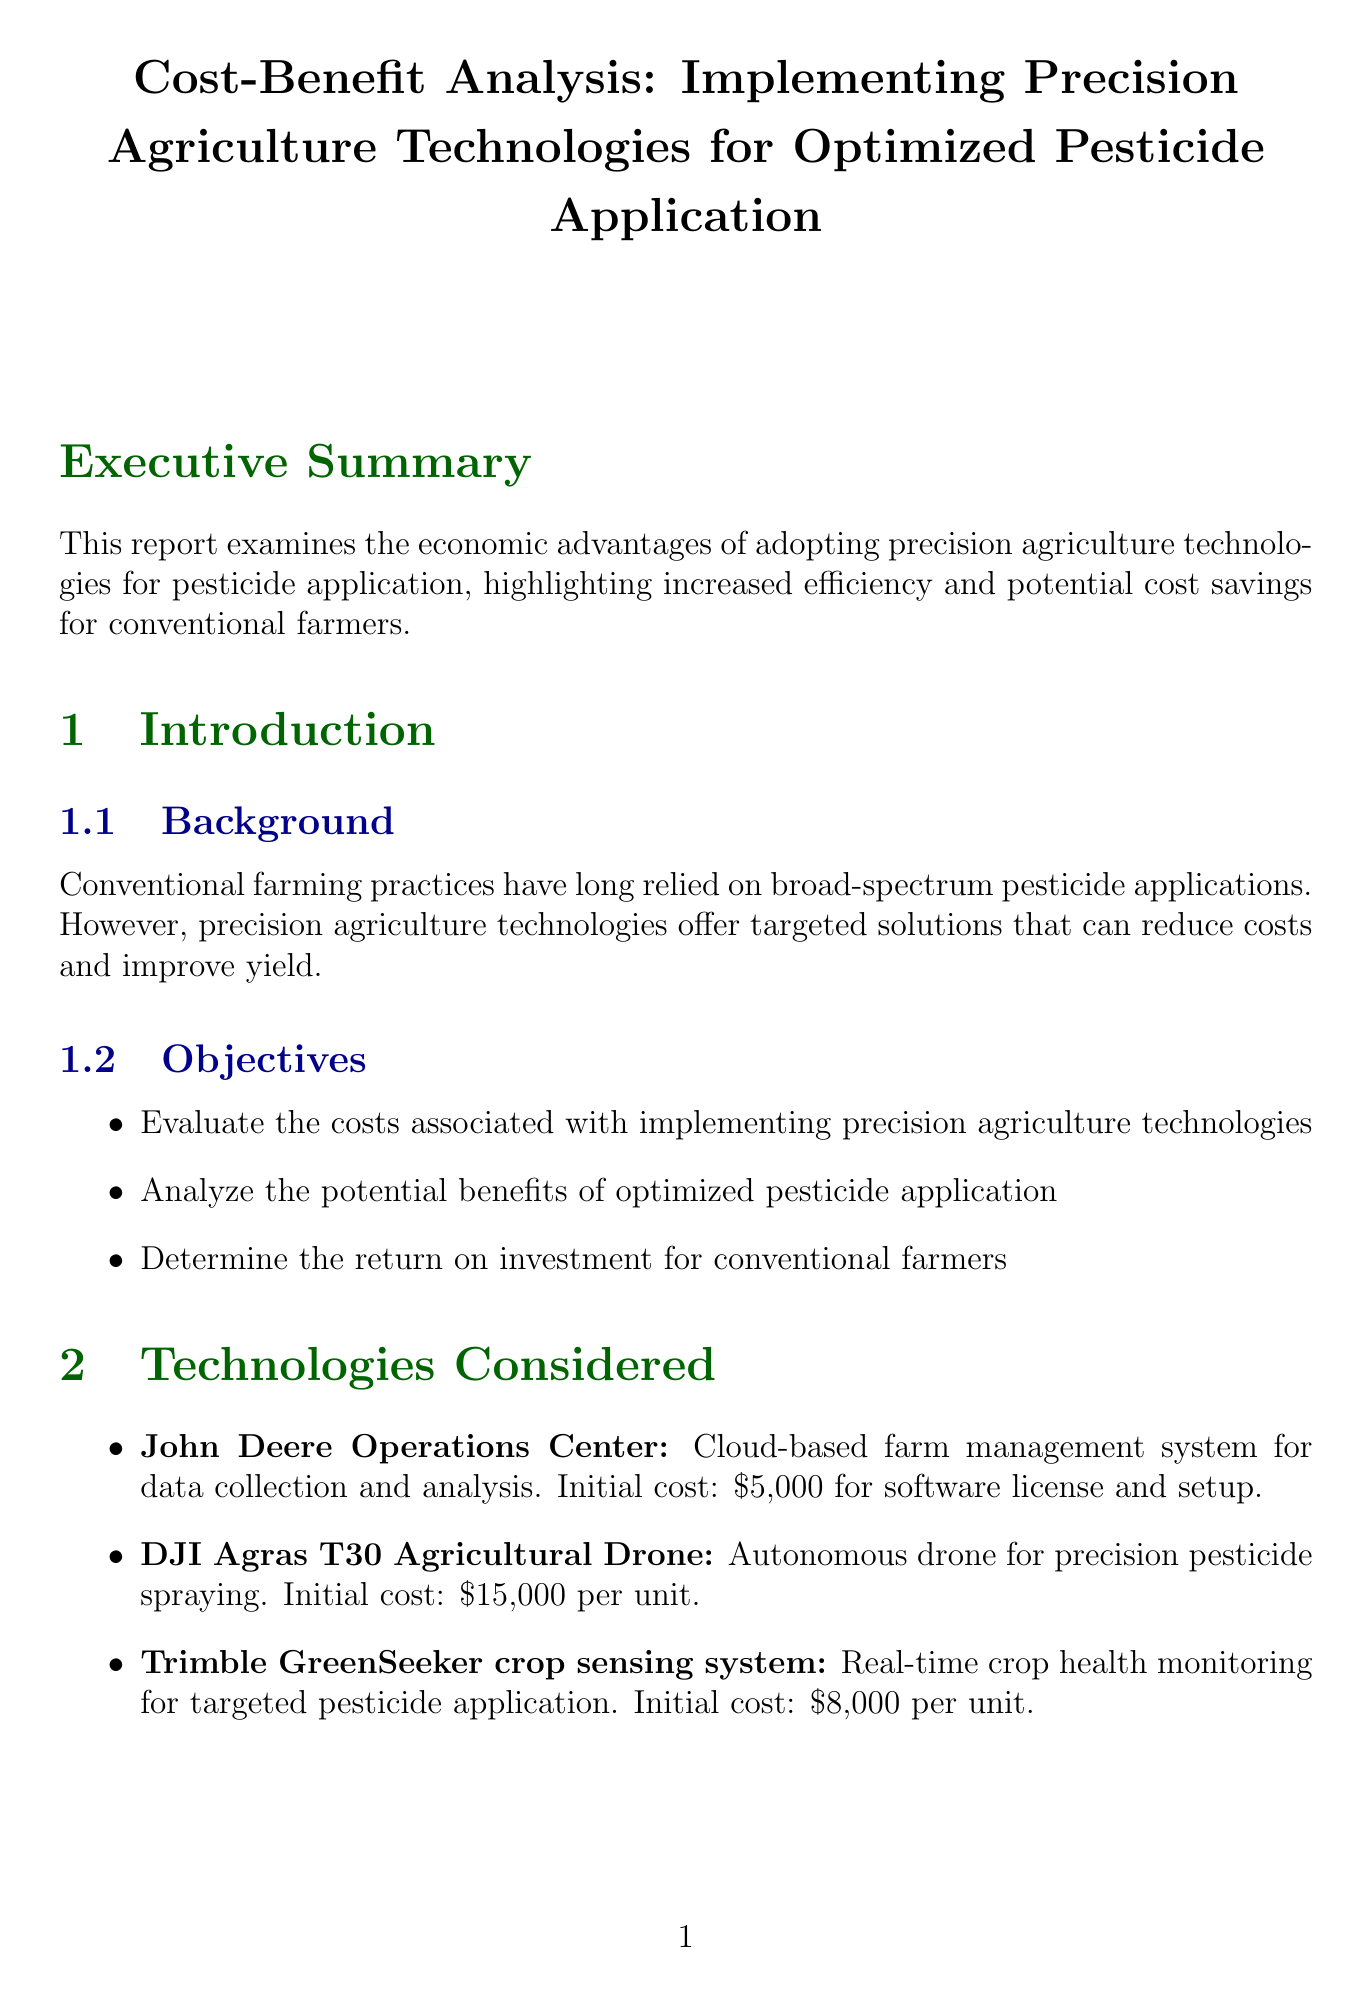What is the title of the report? The title of the report is explicitly mentioned at the beginning of the document.
Answer: Cost-Benefit Analysis: Implementing Precision Agriculture Technologies for Optimized Pesticide Application What is the initial cost of the DJI Agras T30 Agricultural Drone? The initial cost for this specific technology is listed in the technologies considered section.
Answer: $15,000 per unit What is the projected annual savings from reduced pesticide use? The projected savings from reduced pesticide use is specified in the benefit analysis section.
Answer: $10,000 - $15,000 What is the ROI percentage over a 5-year period? The ROI percentage is calculated and stated in the ROI calculation section.
Answer: 234% What is the annual maintenance cost for precision agriculture technologies? The ongoing costs section outlines the maintenance cost specifically.
Answer: $2,000 per year What percentage reduction in pesticide use was observed at Golden Valley Farms? The case study section provides this specific data for Golden Valley Farms.
Answer: 35% Which technology was implemented at Heartland Acres? The results section for Heartland Acres specifies the technologies used.
Answer: John Deere Operations Center and GreenSeeker How many hours of labor are saved per season with precision agriculture technologies? This information is detailed in the benefit analysis section regarding labor efficiency.
Answer: 100 hours per season 